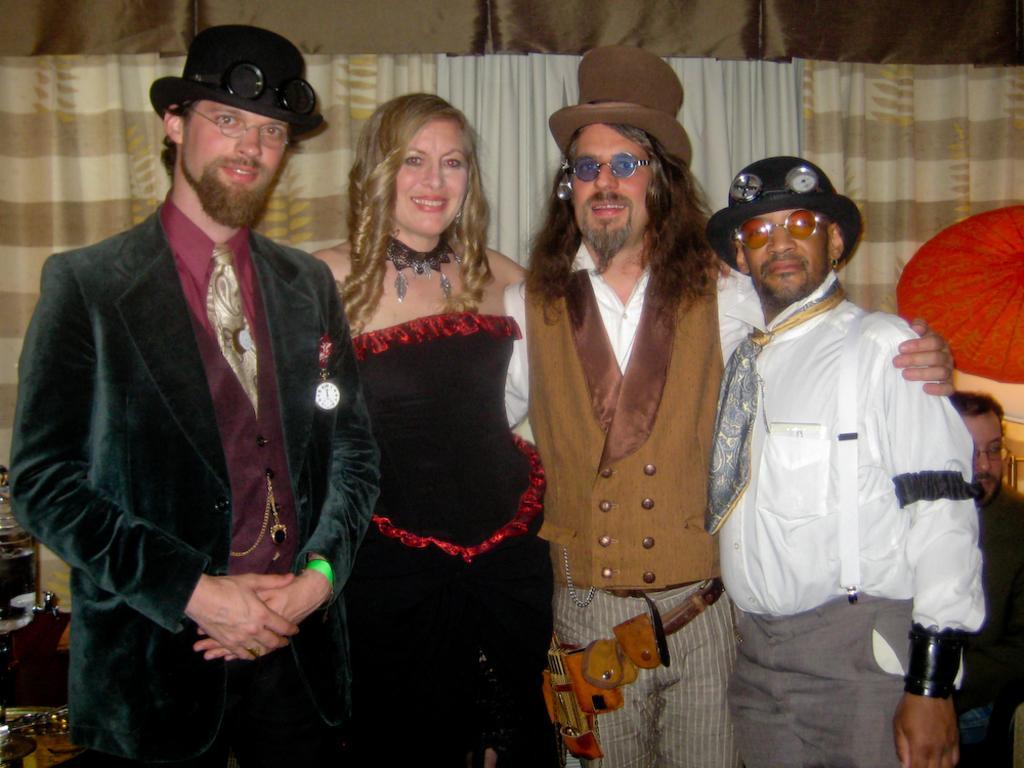Describe this image in one or two sentences. In this image we can see people standing. They are all wearing costumes. In the background there is a curtain. On the left there is a stand. On the right we can see a parasol. There is a man sitting. 